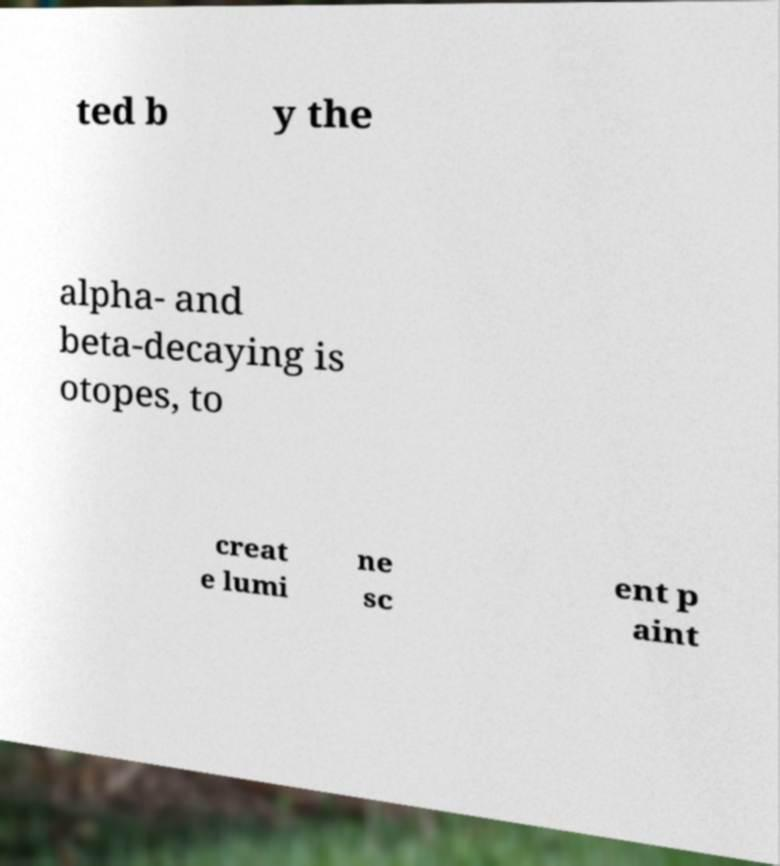Please read and relay the text visible in this image. What does it say? ted b y the alpha- and beta-decaying is otopes, to creat e lumi ne sc ent p aint 